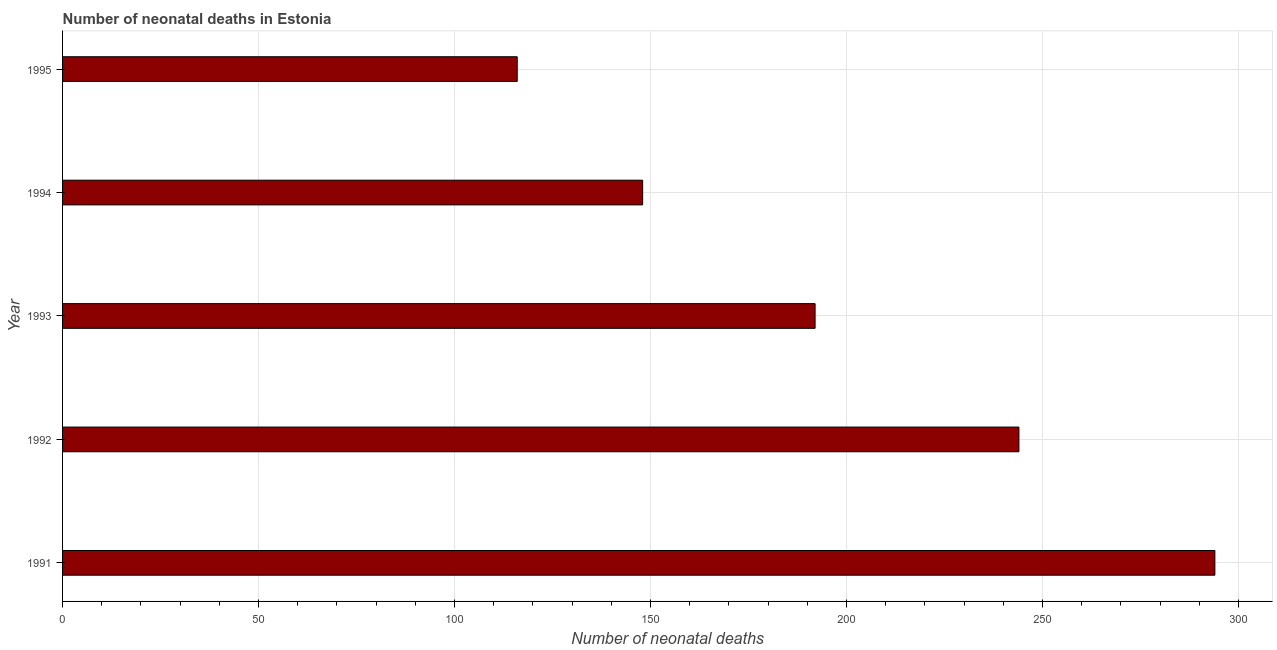Does the graph contain any zero values?
Your response must be concise. No. Does the graph contain grids?
Provide a succinct answer. Yes. What is the title of the graph?
Your answer should be very brief. Number of neonatal deaths in Estonia. What is the label or title of the X-axis?
Give a very brief answer. Number of neonatal deaths. What is the number of neonatal deaths in 1991?
Your answer should be compact. 294. Across all years, what is the maximum number of neonatal deaths?
Your response must be concise. 294. Across all years, what is the minimum number of neonatal deaths?
Keep it short and to the point. 116. In which year was the number of neonatal deaths maximum?
Keep it short and to the point. 1991. In which year was the number of neonatal deaths minimum?
Keep it short and to the point. 1995. What is the sum of the number of neonatal deaths?
Give a very brief answer. 994. What is the average number of neonatal deaths per year?
Ensure brevity in your answer.  198. What is the median number of neonatal deaths?
Offer a terse response. 192. Do a majority of the years between 1993 and 1994 (inclusive) have number of neonatal deaths greater than 220 ?
Offer a terse response. No. What is the ratio of the number of neonatal deaths in 1992 to that in 1993?
Your answer should be compact. 1.27. Is the number of neonatal deaths in 1992 less than that in 1993?
Ensure brevity in your answer.  No. Is the difference between the number of neonatal deaths in 1991 and 1995 greater than the difference between any two years?
Offer a terse response. Yes. What is the difference between the highest and the lowest number of neonatal deaths?
Offer a very short reply. 178. In how many years, is the number of neonatal deaths greater than the average number of neonatal deaths taken over all years?
Offer a very short reply. 2. Are the values on the major ticks of X-axis written in scientific E-notation?
Offer a terse response. No. What is the Number of neonatal deaths of 1991?
Provide a succinct answer. 294. What is the Number of neonatal deaths of 1992?
Provide a succinct answer. 244. What is the Number of neonatal deaths of 1993?
Your response must be concise. 192. What is the Number of neonatal deaths in 1994?
Provide a short and direct response. 148. What is the Number of neonatal deaths in 1995?
Your answer should be very brief. 116. What is the difference between the Number of neonatal deaths in 1991 and 1992?
Offer a very short reply. 50. What is the difference between the Number of neonatal deaths in 1991 and 1993?
Provide a succinct answer. 102. What is the difference between the Number of neonatal deaths in 1991 and 1994?
Ensure brevity in your answer.  146. What is the difference between the Number of neonatal deaths in 1991 and 1995?
Provide a short and direct response. 178. What is the difference between the Number of neonatal deaths in 1992 and 1994?
Provide a short and direct response. 96. What is the difference between the Number of neonatal deaths in 1992 and 1995?
Give a very brief answer. 128. What is the difference between the Number of neonatal deaths in 1993 and 1994?
Offer a terse response. 44. What is the ratio of the Number of neonatal deaths in 1991 to that in 1992?
Give a very brief answer. 1.21. What is the ratio of the Number of neonatal deaths in 1991 to that in 1993?
Provide a succinct answer. 1.53. What is the ratio of the Number of neonatal deaths in 1991 to that in 1994?
Offer a terse response. 1.99. What is the ratio of the Number of neonatal deaths in 1991 to that in 1995?
Your answer should be very brief. 2.53. What is the ratio of the Number of neonatal deaths in 1992 to that in 1993?
Give a very brief answer. 1.27. What is the ratio of the Number of neonatal deaths in 1992 to that in 1994?
Keep it short and to the point. 1.65. What is the ratio of the Number of neonatal deaths in 1992 to that in 1995?
Provide a succinct answer. 2.1. What is the ratio of the Number of neonatal deaths in 1993 to that in 1994?
Provide a short and direct response. 1.3. What is the ratio of the Number of neonatal deaths in 1993 to that in 1995?
Your answer should be compact. 1.66. What is the ratio of the Number of neonatal deaths in 1994 to that in 1995?
Keep it short and to the point. 1.28. 